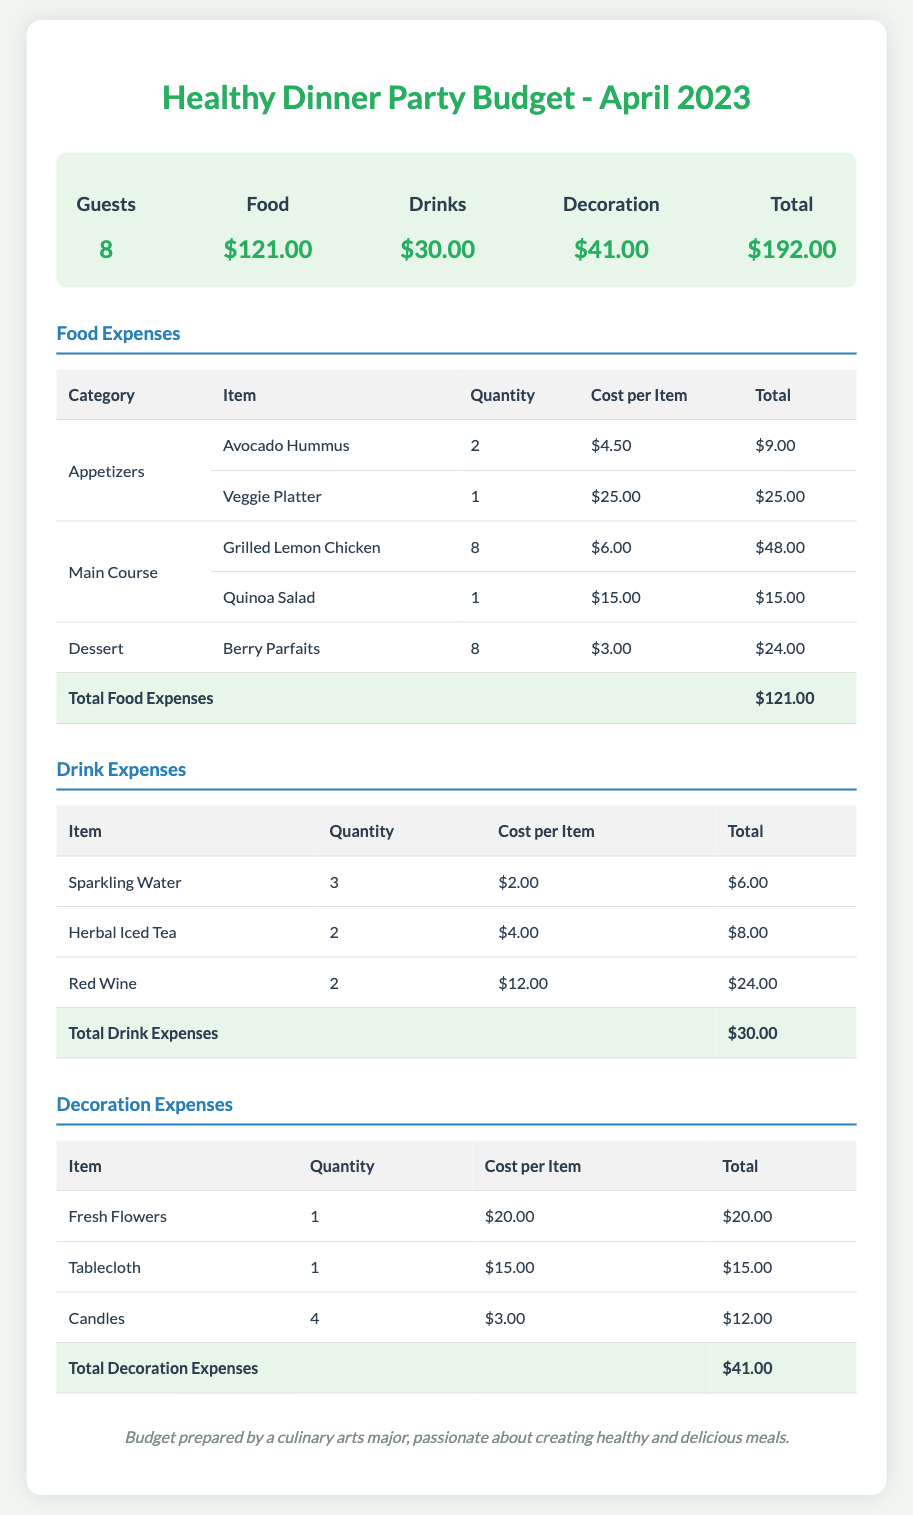What is the total number of guests? The document specifies that there are a total of 8 guests attending the dinner party.
Answer: 8 What is the total cost for drinks? The budget outlines that the total cost for drinks is $30.00.
Answer: $30.00 How much was spent on the Veggie Platter? The document indicates that the Veggie Platter cost $25.00.
Answer: $25.00 What is the total amount spent on decorations? The total amount spent on decorations is specified as $41.00.
Answer: $41.00 Which item had the highest cost in the food category? The Grilled Lemon Chicken, with a total cost of $48.00, is the highest cost item in the food category.
Answer: Grilled Lemon Chicken What is the total cost for the food expenses? The total cost for food expenses is provided in the document as $121.00.
Answer: $121.00 What was the total cost for candles in the decoration expenses? The total cost for the candles is stated as $12.00 within the decoration expenses.
Answer: $12.00 How many types of drinks are listed in the document? There are three types of drinks mentioned: Sparkling Water, Herbal Iced Tea, and Red Wine.
Answer: 3 What is the total budget calculated for the dinner party? The total budget for the healthy dinner party amounts to $192.00, as per the summary section.
Answer: $192.00 